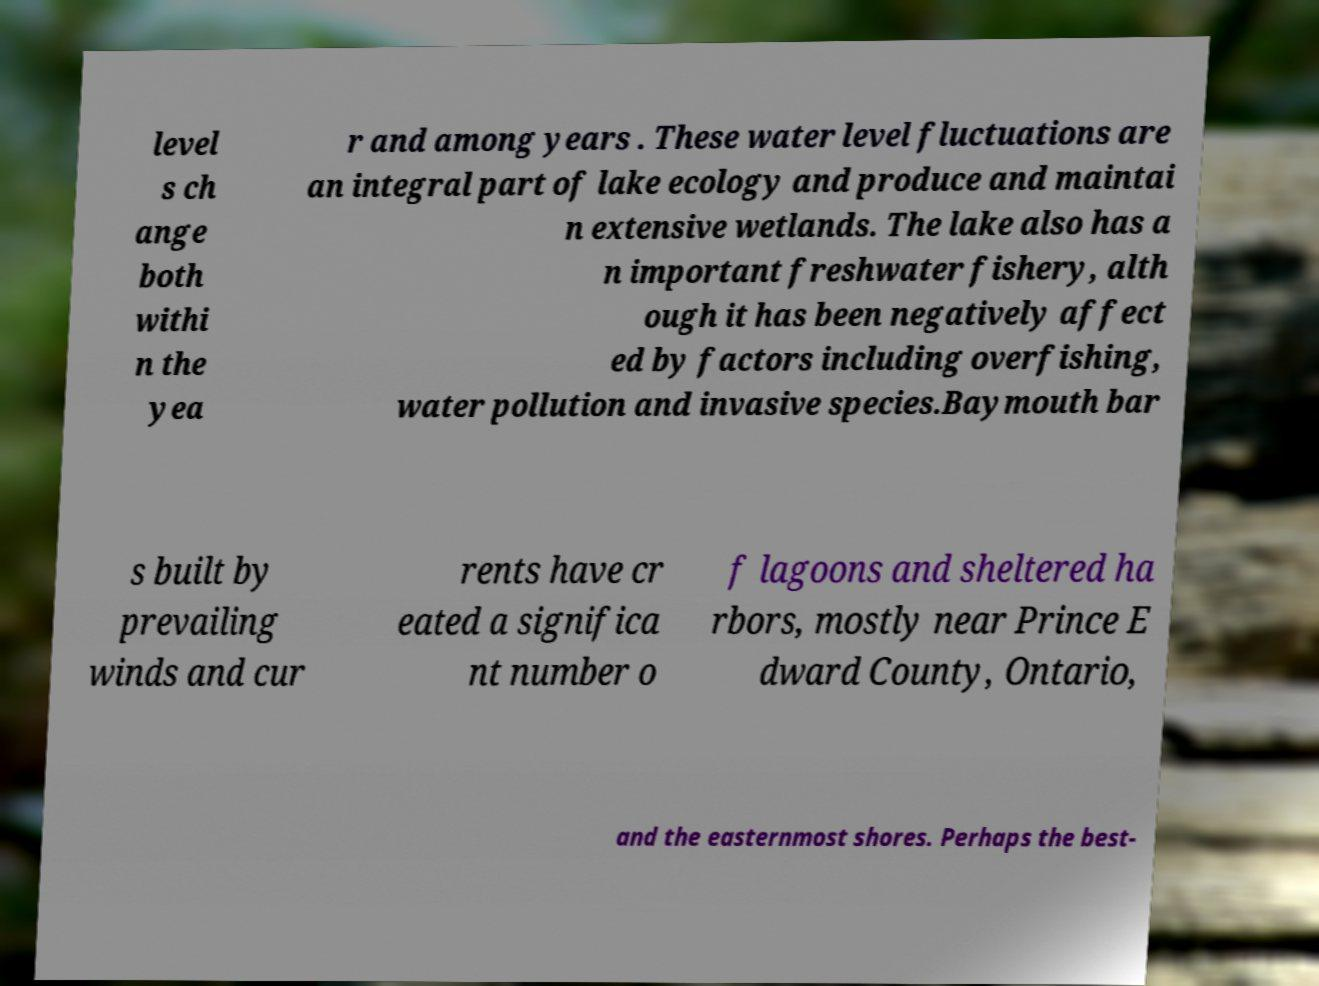Can you read and provide the text displayed in the image?This photo seems to have some interesting text. Can you extract and type it out for me? level s ch ange both withi n the yea r and among years . These water level fluctuations are an integral part of lake ecology and produce and maintai n extensive wetlands. The lake also has a n important freshwater fishery, alth ough it has been negatively affect ed by factors including overfishing, water pollution and invasive species.Baymouth bar s built by prevailing winds and cur rents have cr eated a significa nt number o f lagoons and sheltered ha rbors, mostly near Prince E dward County, Ontario, and the easternmost shores. Perhaps the best- 